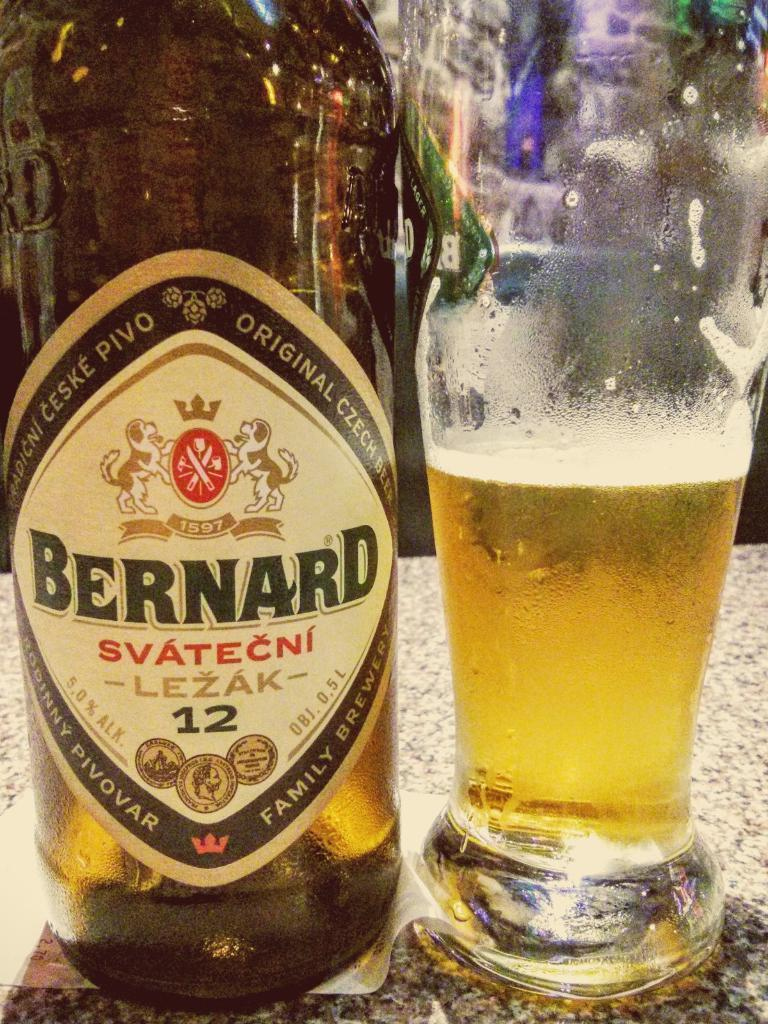<image>
Describe the image concisely. A bottle of Bernard sits next to a glass 